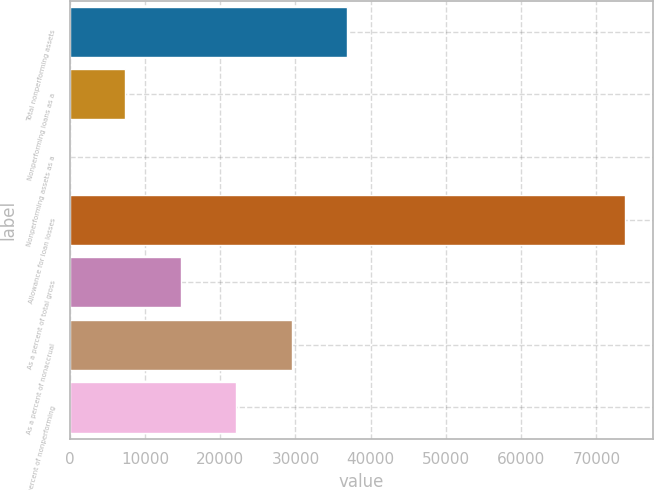<chart> <loc_0><loc_0><loc_500><loc_500><bar_chart><fcel>Total nonperforming assets<fcel>Nonperforming loans as a<fcel>Nonperforming assets as a<fcel>Allowance for loan losses<fcel>As a percent of total gross<fcel>As a percent of nonaccrual<fcel>As a percent of nonperforming<nl><fcel>36900.2<fcel>7380.27<fcel>0.3<fcel>73800<fcel>14760.2<fcel>29520.2<fcel>22140.2<nl></chart> 